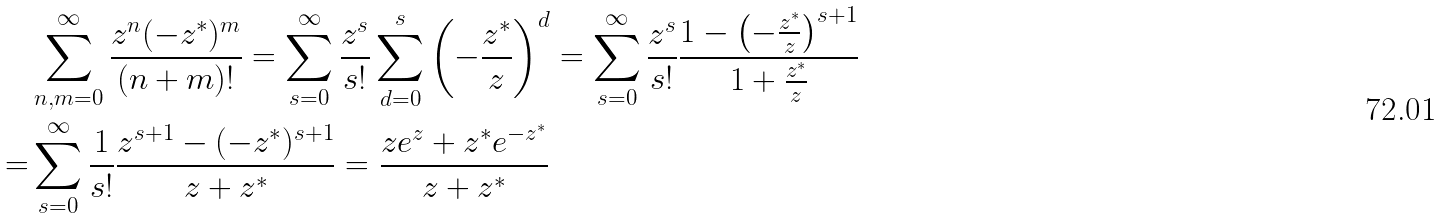Convert formula to latex. <formula><loc_0><loc_0><loc_500><loc_500>& \sum _ { n , m = 0 } ^ { \infty } \frac { z ^ { n } ( - z ^ { * } ) ^ { m } } { ( n + m ) ! } = \sum _ { s = 0 } ^ { \infty } \frac { z ^ { s } } { s ! } \sum _ { d = 0 } ^ { s } \left ( - \frac { z ^ { * } } { z } \right ) ^ { d } = \sum _ { s = 0 } ^ { \infty } \frac { z ^ { s } } { s ! } \frac { 1 - \left ( - \frac { z ^ { * } } { z } \right ) ^ { s + 1 } } { 1 + \frac { z ^ { * } } { z } } \\ = & \sum _ { s = 0 } ^ { \infty } \frac { 1 } { s ! } \frac { z ^ { s + 1 } - ( - z ^ { * } ) ^ { s + 1 } } { z + z ^ { * } } = \frac { z e ^ { z } + z ^ { * } e ^ { - z ^ { * } } } { z + z ^ { * } }</formula> 